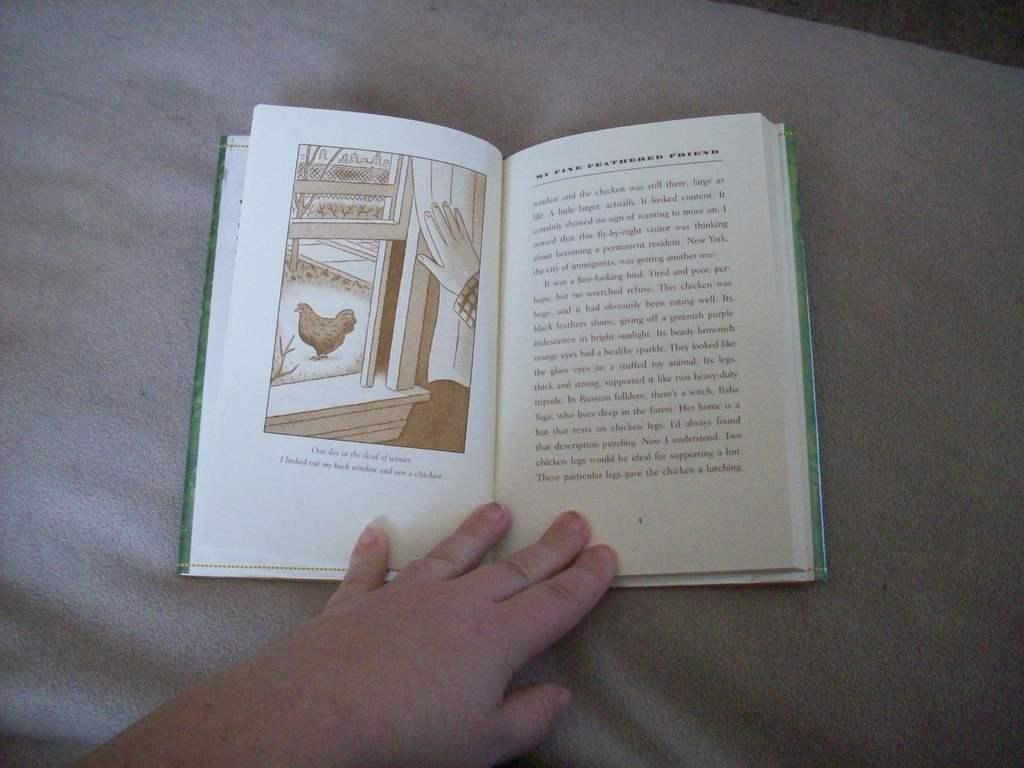What animal you  can see in the picture?
Offer a very short reply. Answering does not require reading text in the image. 